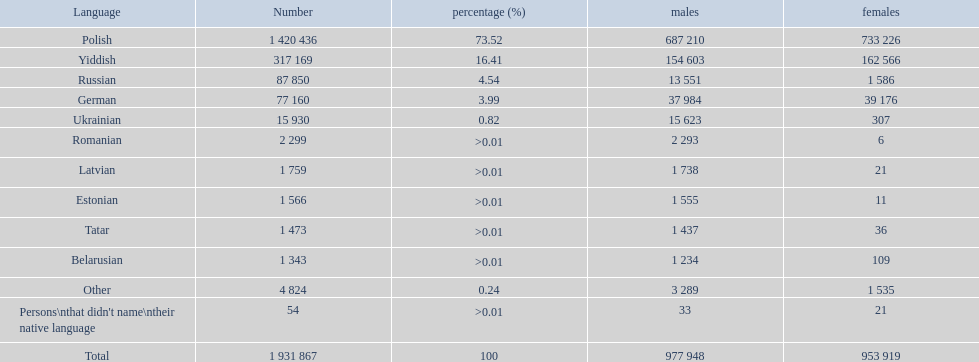How many languages are displayed? Polish, Yiddish, Russian, German, Ukrainian, Romanian, Latvian, Estonian, Tatar, Belarusian, Other. Which language is in the third position? Russian. Following that language, which one is the most spoken? German. 